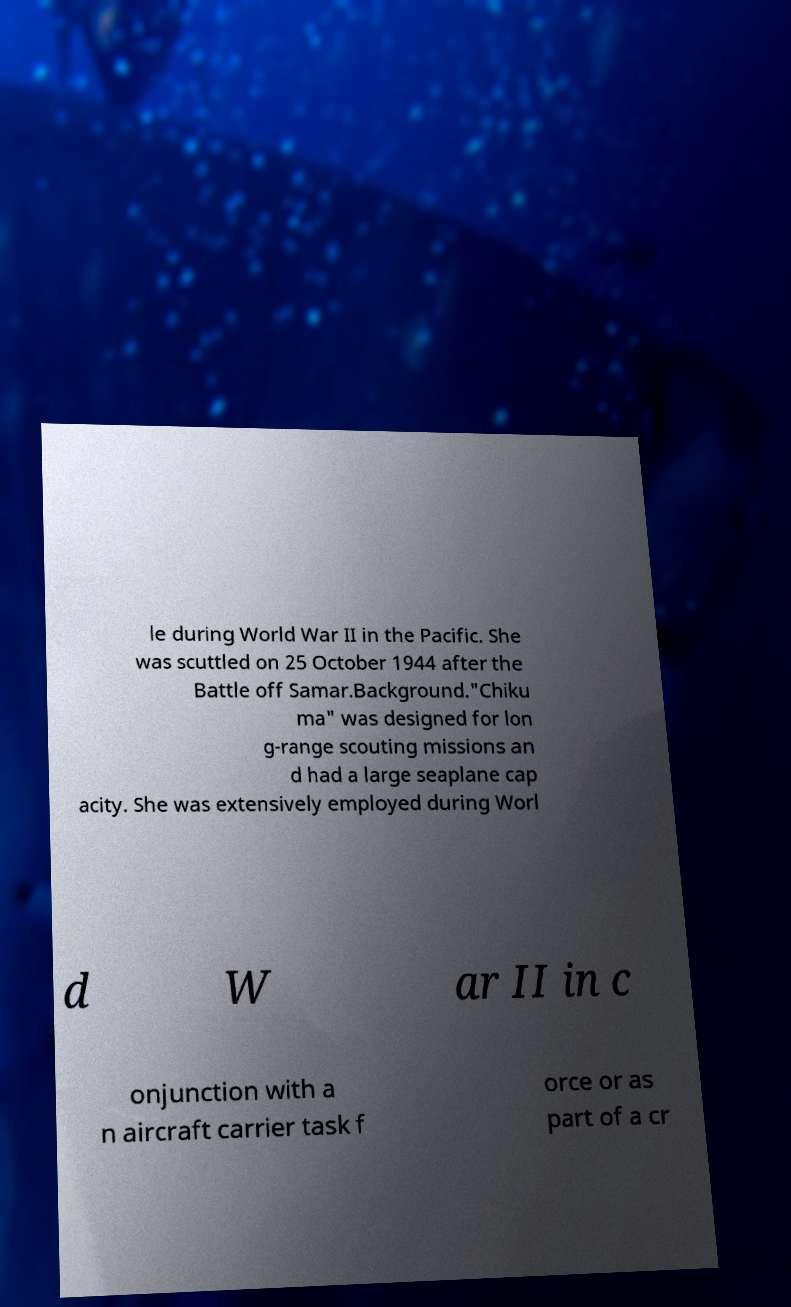Can you accurately transcribe the text from the provided image for me? le during World War II in the Pacific. She was scuttled on 25 October 1944 after the Battle off Samar.Background."Chiku ma" was designed for lon g-range scouting missions an d had a large seaplane cap acity. She was extensively employed during Worl d W ar II in c onjunction with a n aircraft carrier task f orce or as part of a cr 